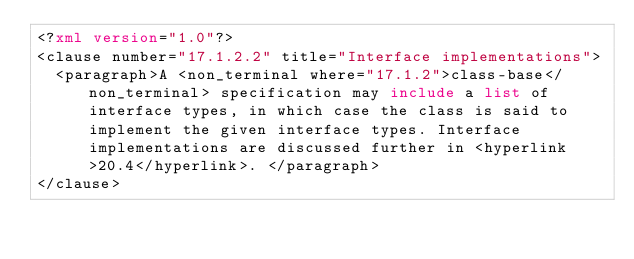Convert code to text. <code><loc_0><loc_0><loc_500><loc_500><_XML_><?xml version="1.0"?>
<clause number="17.1.2.2" title="Interface implementations">
  <paragraph>A <non_terminal where="17.1.2">class-base</non_terminal> specification may include a list of interface types, in which case the class is said to implement the given interface types. Interface implementations are discussed further in <hyperlink>20.4</hyperlink>. </paragraph>
</clause>
</code> 